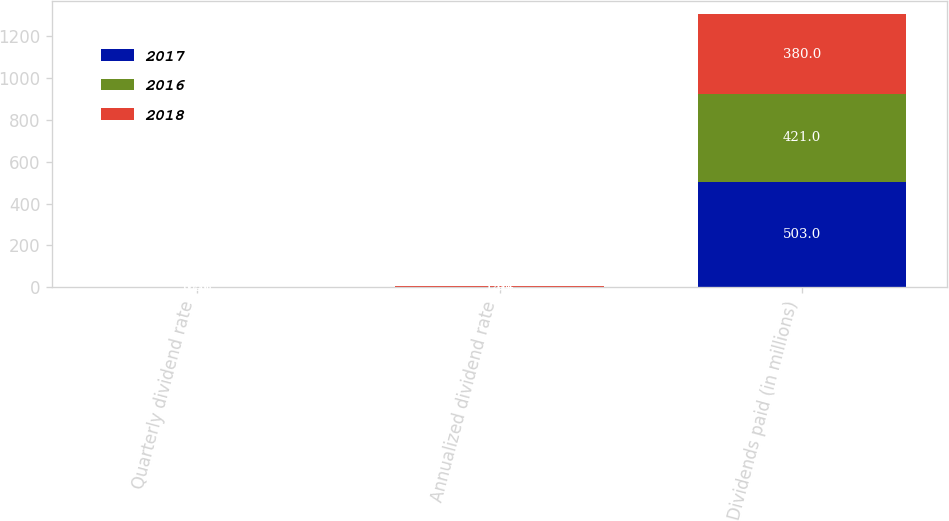<chart> <loc_0><loc_0><loc_500><loc_500><stacked_bar_chart><ecel><fcel>Quarterly dividend rate<fcel>Annualized dividend rate<fcel>Dividends paid (in millions)<nl><fcel>2017<fcel>0.5<fcel>2<fcel>503<nl><fcel>2016<fcel>0.41<fcel>1.64<fcel>421<nl><fcel>2018<fcel>0.36<fcel>1.44<fcel>380<nl></chart> 